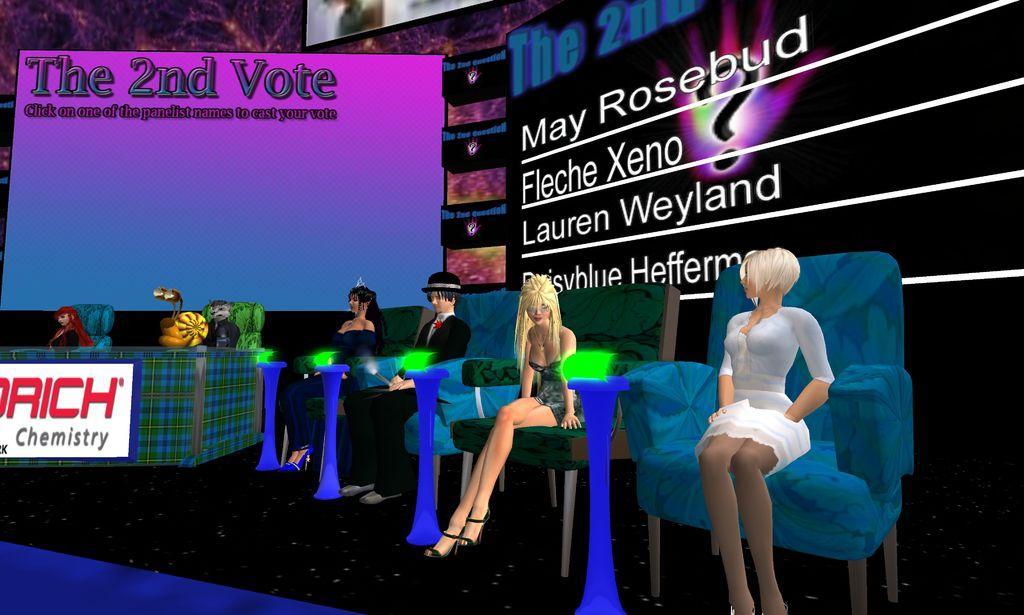Please provide a concise description of this image. In this image I can see few cartoon person sitting and they are wearing multi color dresses, background I can see few screens in black, pink and blue color. 